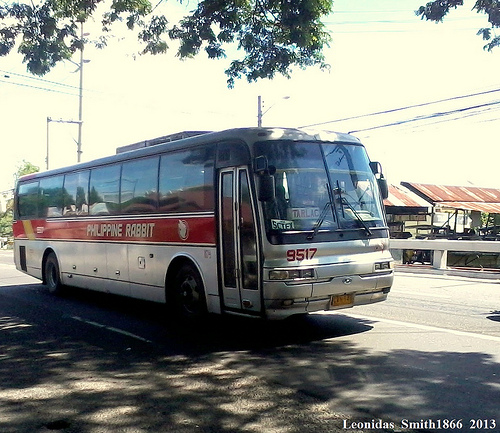<image>
Is there a bus in front of the road? No. The bus is not in front of the road. The spatial positioning shows a different relationship between these objects. 